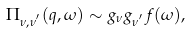Convert formula to latex. <formula><loc_0><loc_0><loc_500><loc_500>\Pi _ { \nu , \nu ^ { ^ { \prime } } } ( { q } , \omega ) \sim g _ { \nu } g _ { \nu ^ { ^ { \prime } } } f ( \omega ) ,</formula> 